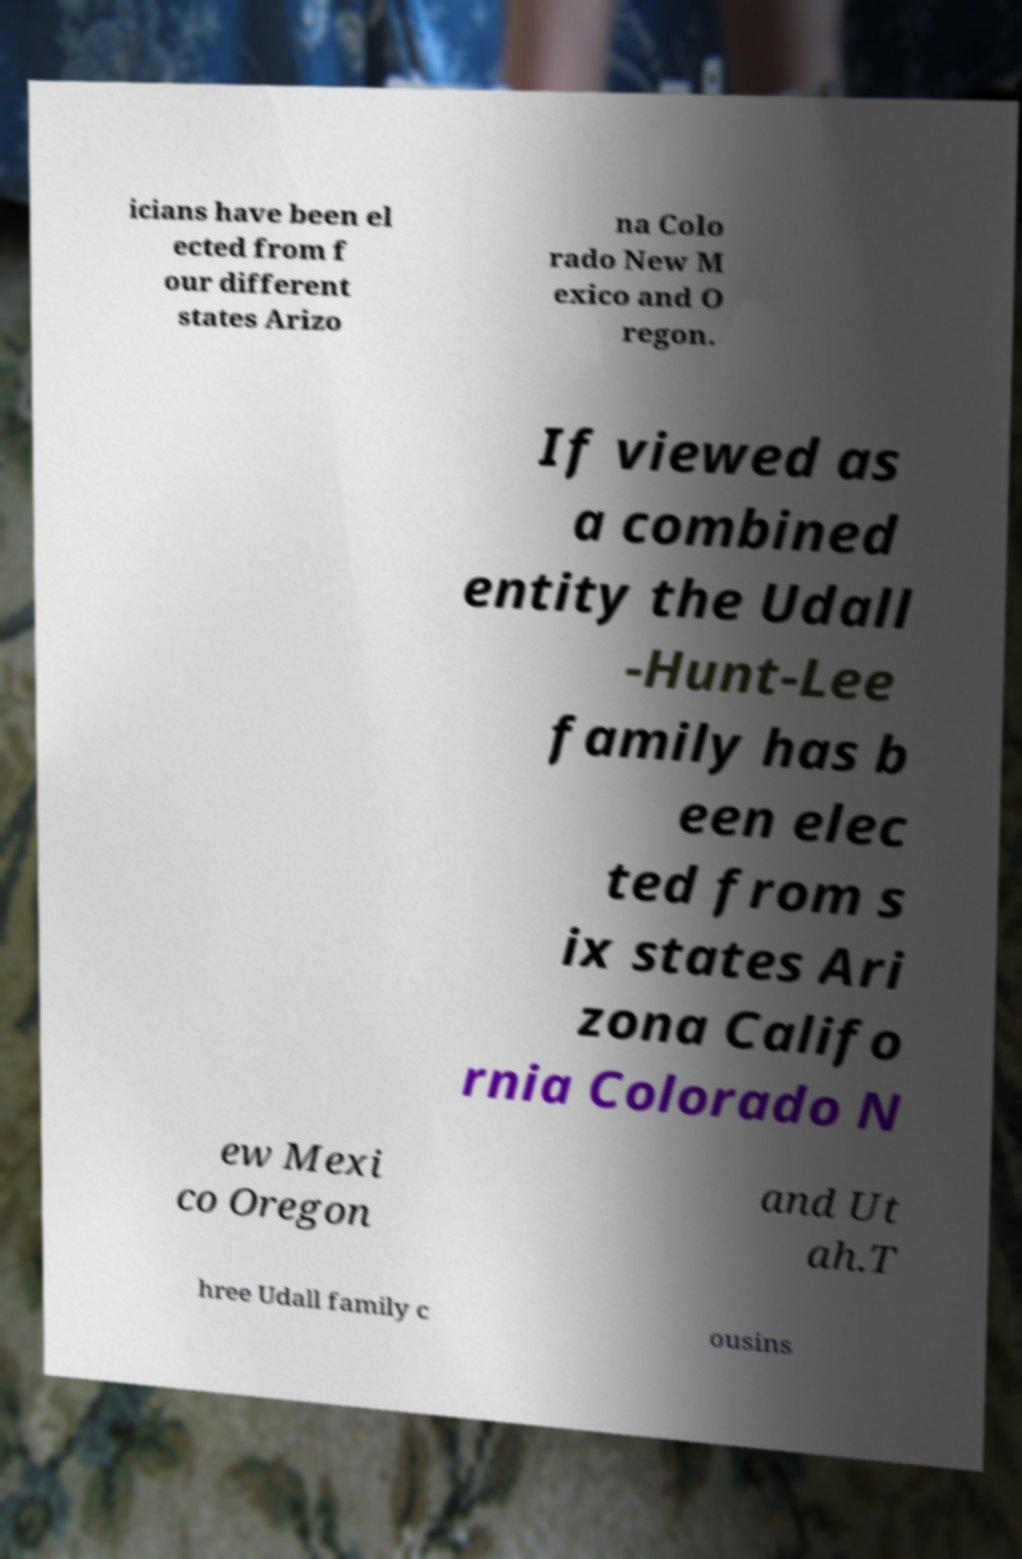I need the written content from this picture converted into text. Can you do that? icians have been el ected from f our different states Arizo na Colo rado New M exico and O regon. If viewed as a combined entity the Udall -Hunt-Lee family has b een elec ted from s ix states Ari zona Califo rnia Colorado N ew Mexi co Oregon and Ut ah.T hree Udall family c ousins 